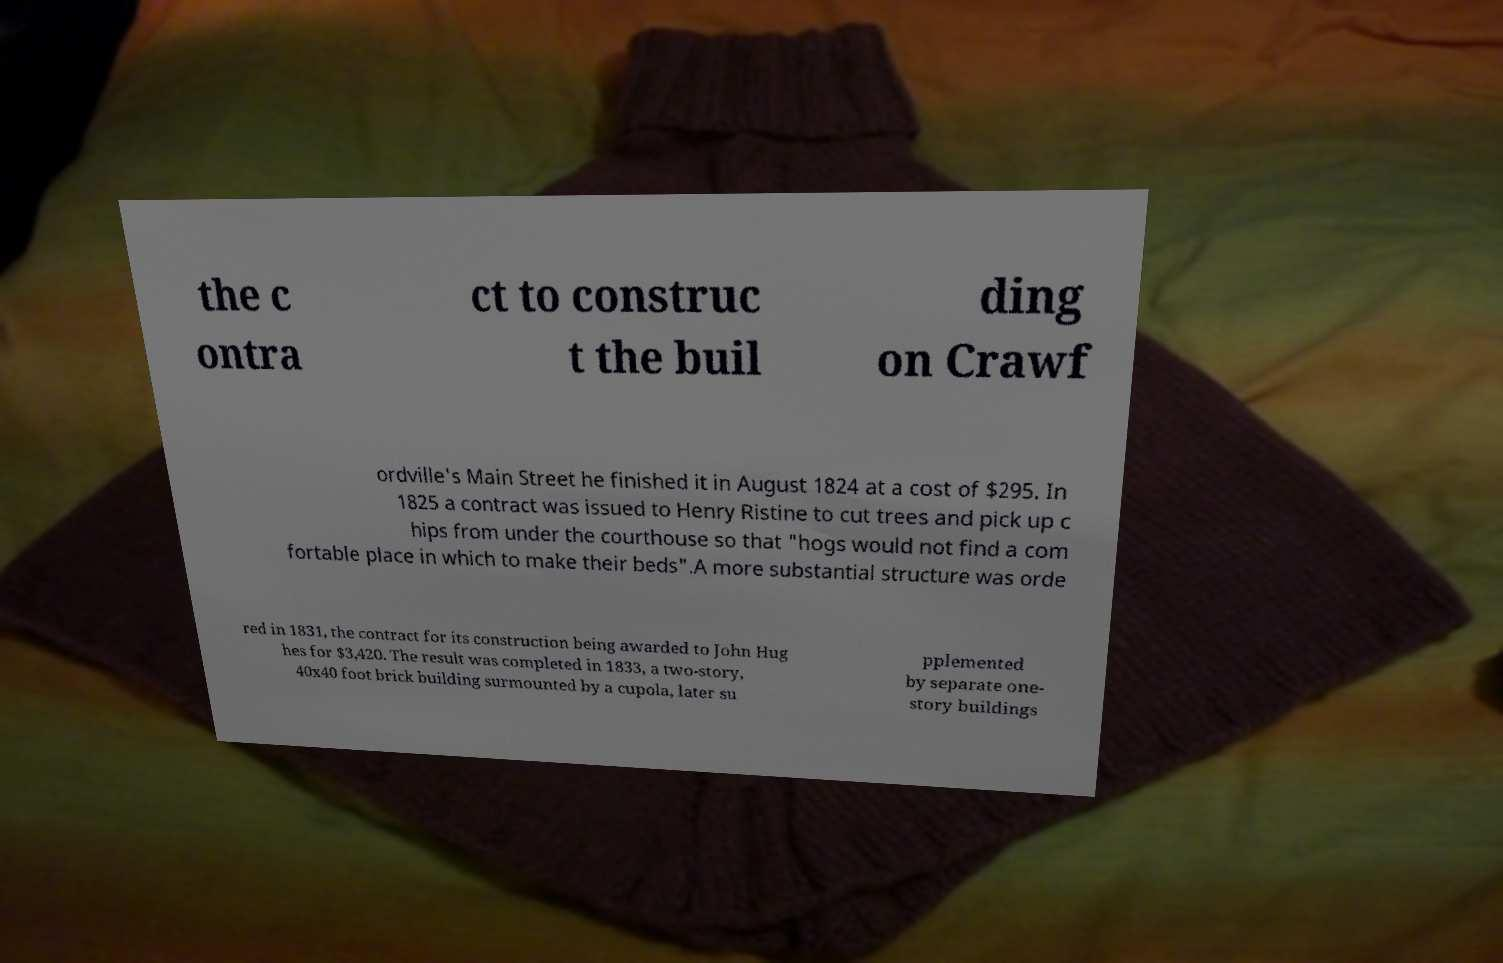Can you accurately transcribe the text from the provided image for me? the c ontra ct to construc t the buil ding on Crawf ordville's Main Street he finished it in August 1824 at a cost of $295. In 1825 a contract was issued to Henry Ristine to cut trees and pick up c hips from under the courthouse so that "hogs would not find a com fortable place in which to make their beds".A more substantial structure was orde red in 1831, the contract for its construction being awarded to John Hug hes for $3,420. The result was completed in 1833, a two-story, 40x40 foot brick building surmounted by a cupola, later su pplemented by separate one- story buildings 